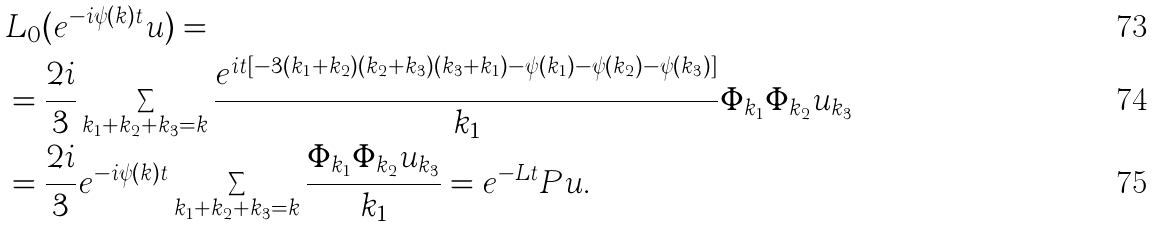<formula> <loc_0><loc_0><loc_500><loc_500>& L _ { 0 } ( e ^ { - i \psi ( k ) t } u ) = \\ & = \frac { 2 i } { 3 } \sum _ { k _ { 1 } + k _ { 2 } + k _ { 3 } = k } \frac { e ^ { i t [ - 3 ( k _ { 1 } + k _ { 2 } ) ( k _ { 2 } + k _ { 3 } ) ( k _ { 3 } + k _ { 1 } ) - \psi ( k _ { 1 } ) - \psi ( k _ { 2 } ) - \psi ( k _ { 3 } ) ] } } { k _ { 1 } } \Phi _ { k _ { 1 } } \Phi _ { k _ { 2 } } u _ { k _ { 3 } } \\ & = \frac { 2 i } { 3 } e ^ { - i \psi ( k ) t } \sum _ { k _ { 1 } + k _ { 2 } + k _ { 3 } = k } \frac { \Phi _ { k _ { 1 } } \Phi _ { k _ { 2 } } u _ { k _ { 3 } } } { k _ { 1 } } = e ^ { - L t } P u .</formula> 